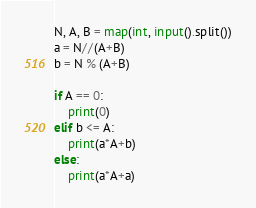Convert code to text. <code><loc_0><loc_0><loc_500><loc_500><_Python_>N, A, B = map(int, input().split())
a = N//(A+B)
b = N % (A+B)

if A == 0:
    print(0)
elif b <= A:
    print(a*A+b)
else:
    print(a*A+a)</code> 